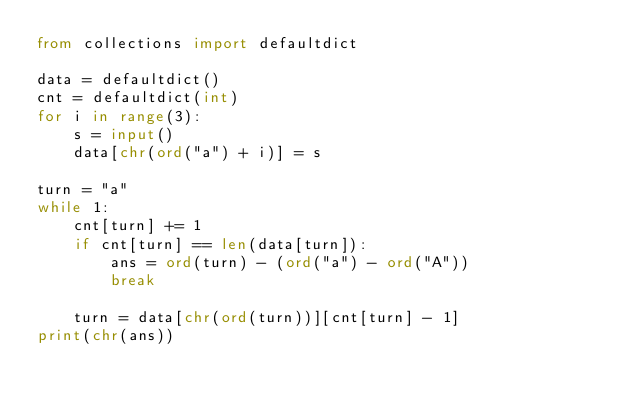Convert code to text. <code><loc_0><loc_0><loc_500><loc_500><_Python_>from collections import defaultdict

data = defaultdict()
cnt = defaultdict(int)
for i in range(3):
    s = input()
    data[chr(ord("a") + i)] = s

turn = "a"
while 1:
    cnt[turn] += 1
    if cnt[turn] == len(data[turn]):
        ans = ord(turn) - (ord("a") - ord("A"))
        break

    turn = data[chr(ord(turn))][cnt[turn] - 1]
print(chr(ans))</code> 